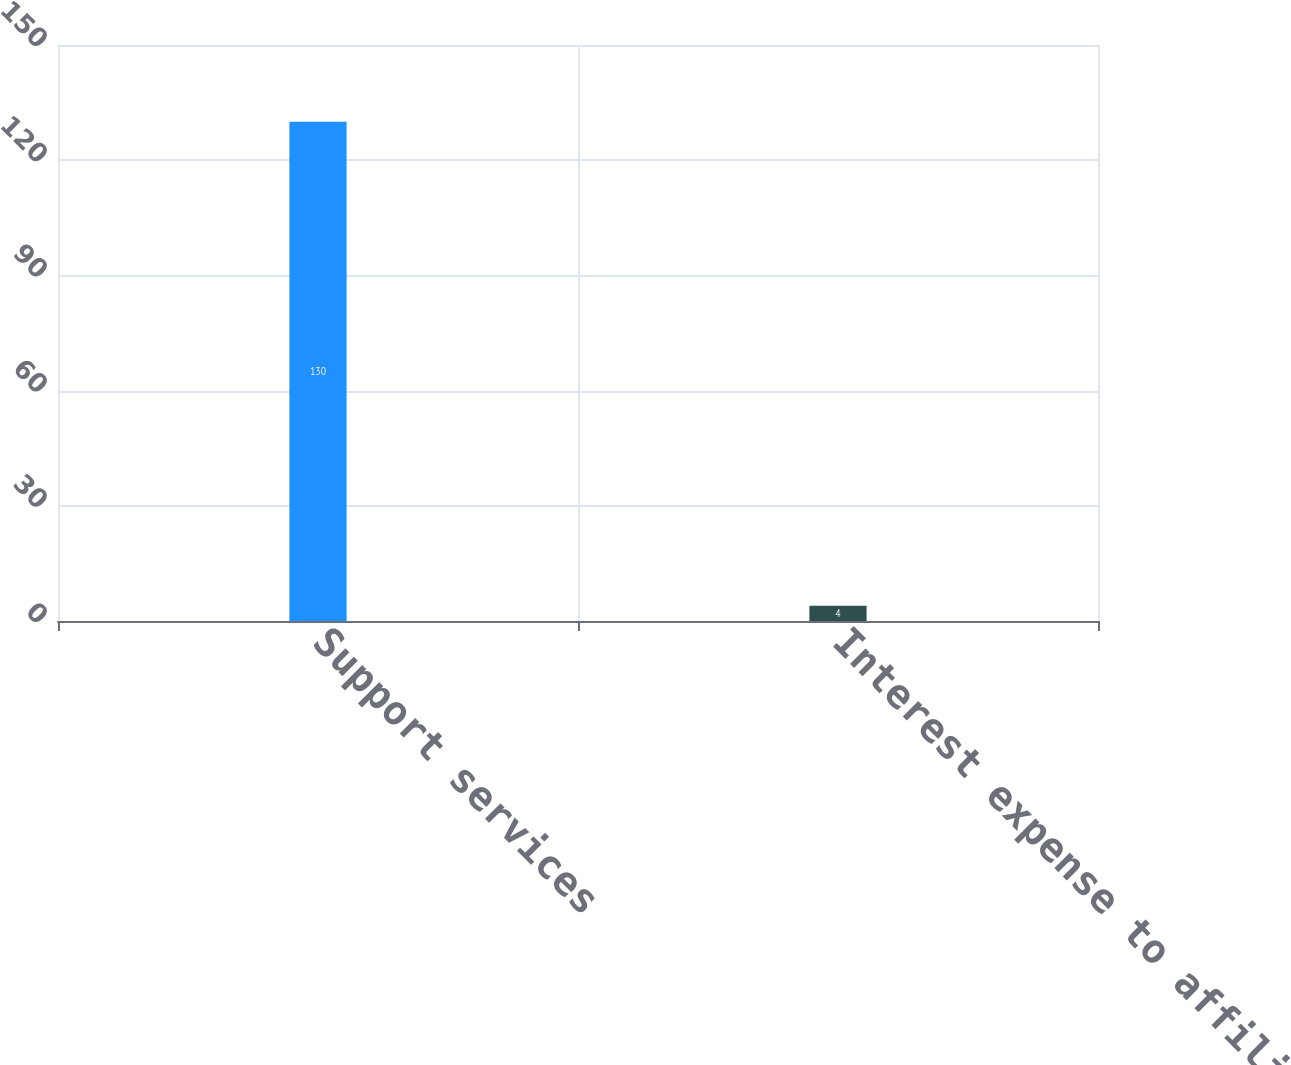Convert chart. <chart><loc_0><loc_0><loc_500><loc_500><bar_chart><fcel>Support services<fcel>Interest expense to affiliates<nl><fcel>130<fcel>4<nl></chart> 